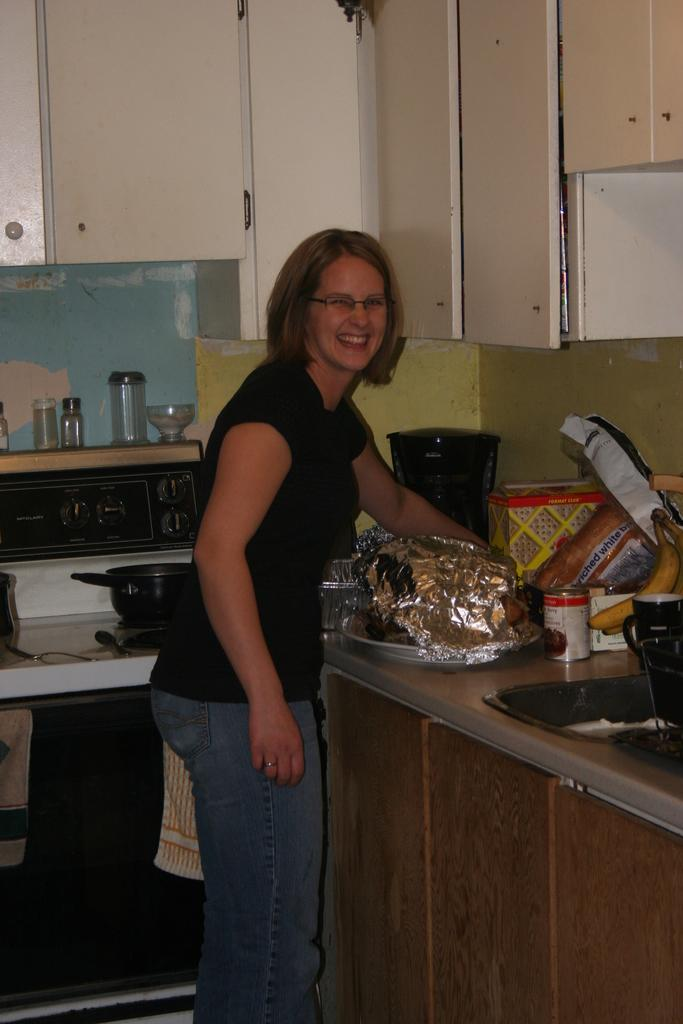Provide a one-sentence caption for the provided image. a smiling woman reaching for a loaf of WHITE BREAD in a kitchen. 